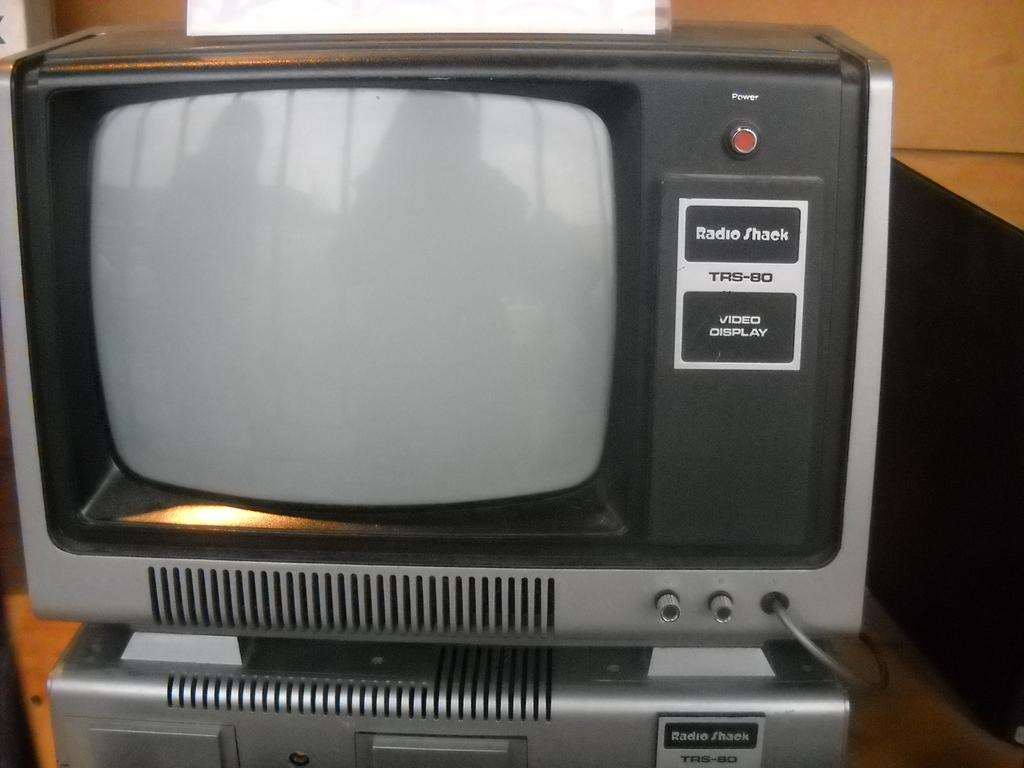What is the main object in the image? There is a device in the image. Can you describe the background in the image? There is a background in the image, but without more information, we cannot provide specific details about it. What type of gold jewelry is being discussed in the meeting in the image? There is no meeting or gold jewelry present in the image; it only features a device and a background. 